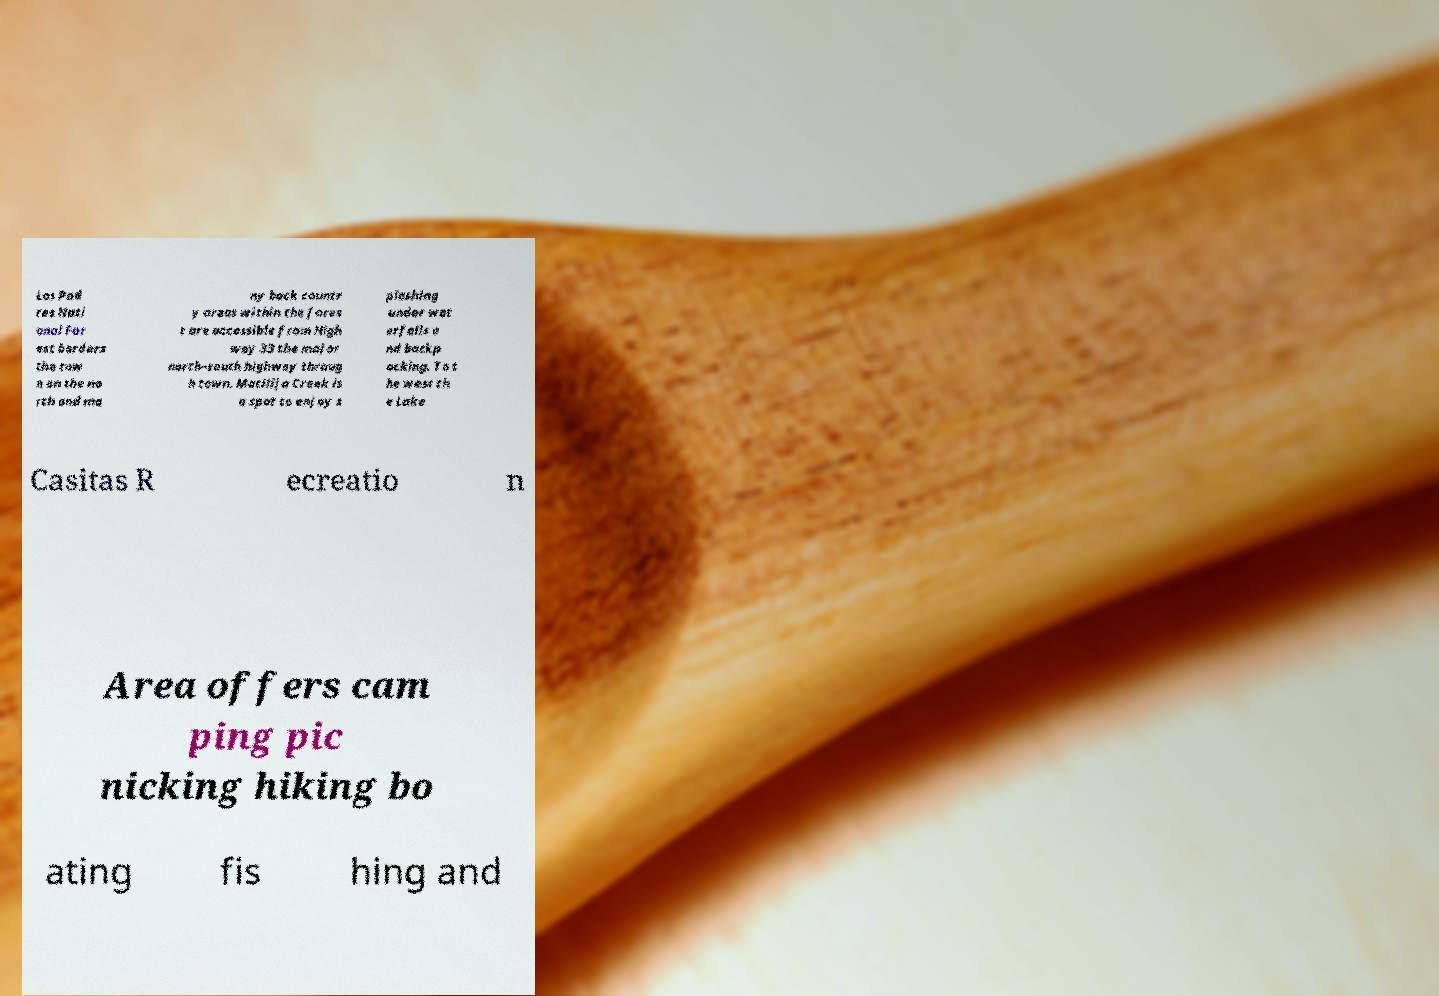Please identify and transcribe the text found in this image. Los Pad res Nati onal For est borders the tow n on the no rth and ma ny back countr y areas within the fores t are accessible from High way 33 the major north–south highway throug h town. Matilija Creek is a spot to enjoy s plashing under wat erfalls a nd backp acking. To t he west th e Lake Casitas R ecreatio n Area offers cam ping pic nicking hiking bo ating fis hing and 